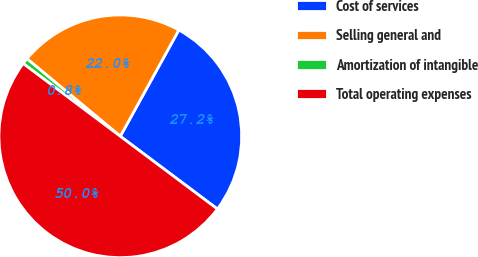Convert chart. <chart><loc_0><loc_0><loc_500><loc_500><pie_chart><fcel>Cost of services<fcel>Selling general and<fcel>Amortization of intangible<fcel>Total operating expenses<nl><fcel>27.22%<fcel>21.98%<fcel>0.8%<fcel>50.0%<nl></chart> 